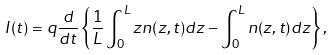<formula> <loc_0><loc_0><loc_500><loc_500>I ( t ) = q \frac { d } { d t } \left \{ \frac { 1 } { L } \int _ { 0 } ^ { L } z n ( z , t ) d z - \int _ { 0 } ^ { L } n ( z , t ) d z \right \} ,</formula> 